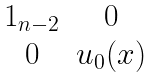Convert formula to latex. <formula><loc_0><loc_0><loc_500><loc_500>\begin{matrix} 1 _ { n - 2 } & 0 \\ 0 & u _ { 0 } ( x ) \end{matrix}</formula> 